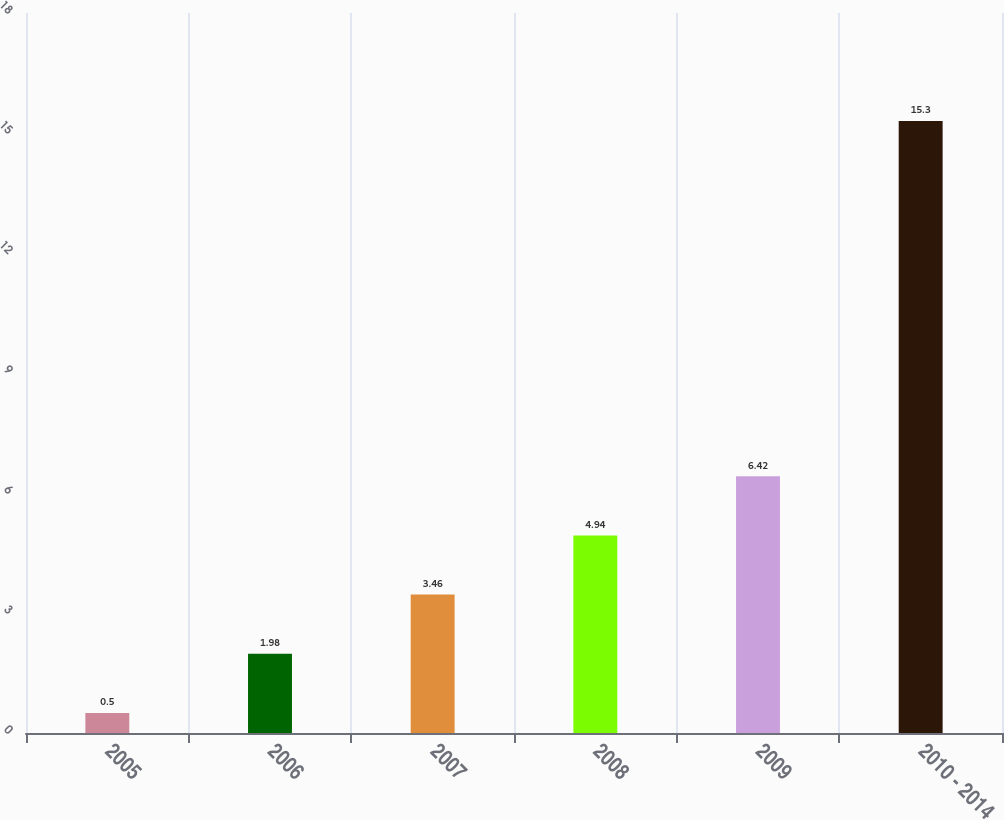Convert chart. <chart><loc_0><loc_0><loc_500><loc_500><bar_chart><fcel>2005<fcel>2006<fcel>2007<fcel>2008<fcel>2009<fcel>2010 - 2014<nl><fcel>0.5<fcel>1.98<fcel>3.46<fcel>4.94<fcel>6.42<fcel>15.3<nl></chart> 